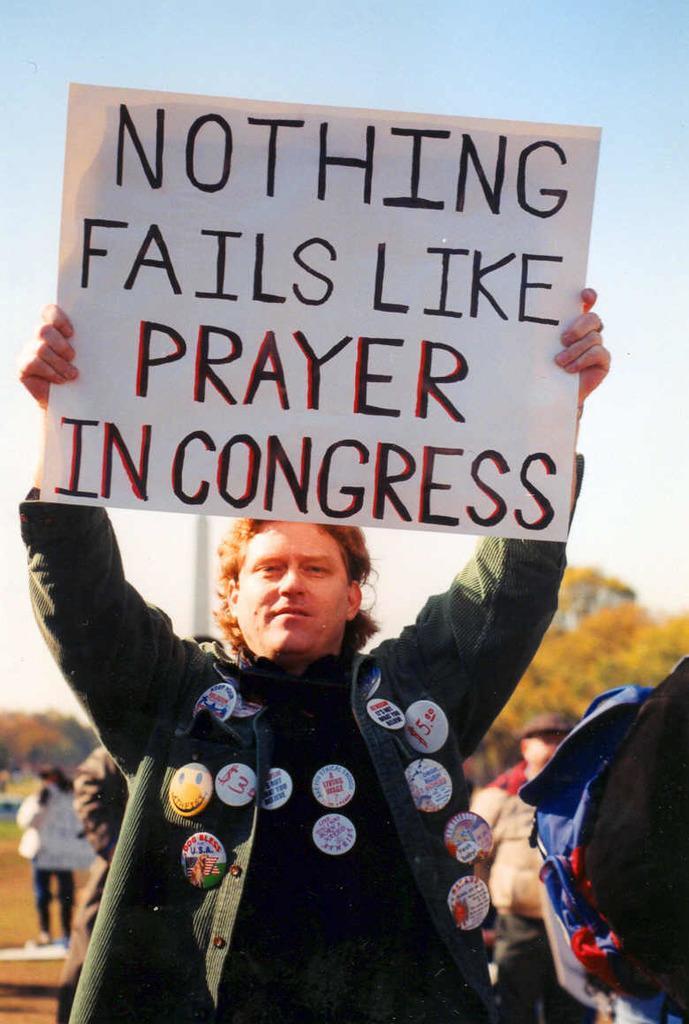In one or two sentences, can you explain what this image depicts? In this picture we can see a person is standing and holding a card, there is some text on the card, there are two persons standing in the middle, in the background we can see trees, there is the sky at the top of the picture. 